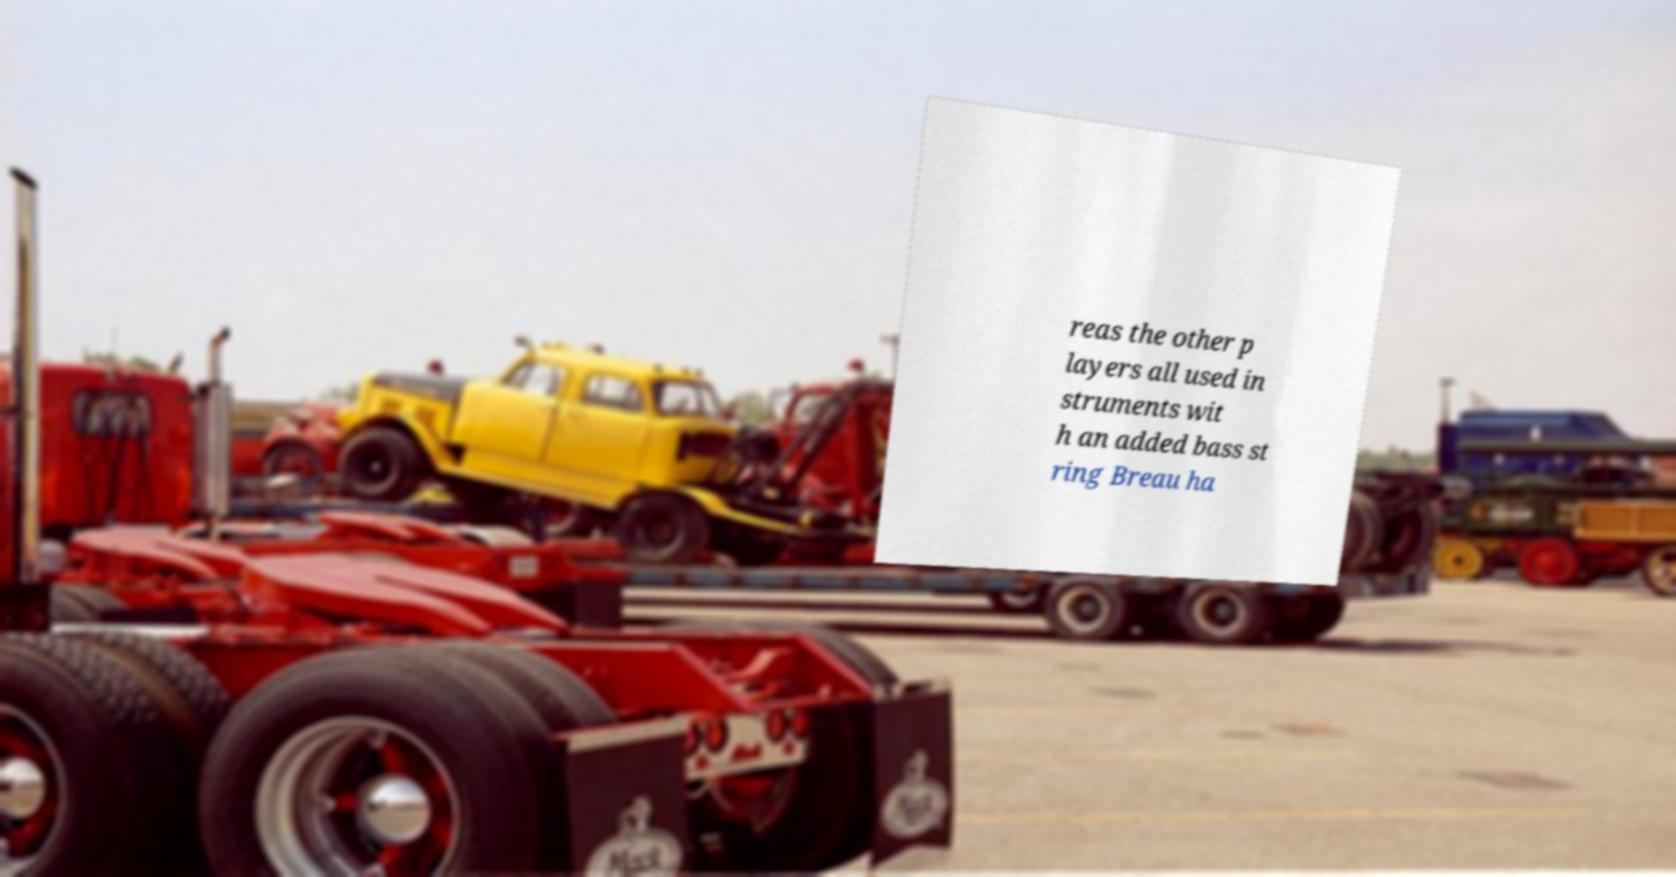Please read and relay the text visible in this image. What does it say? reas the other p layers all used in struments wit h an added bass st ring Breau ha 